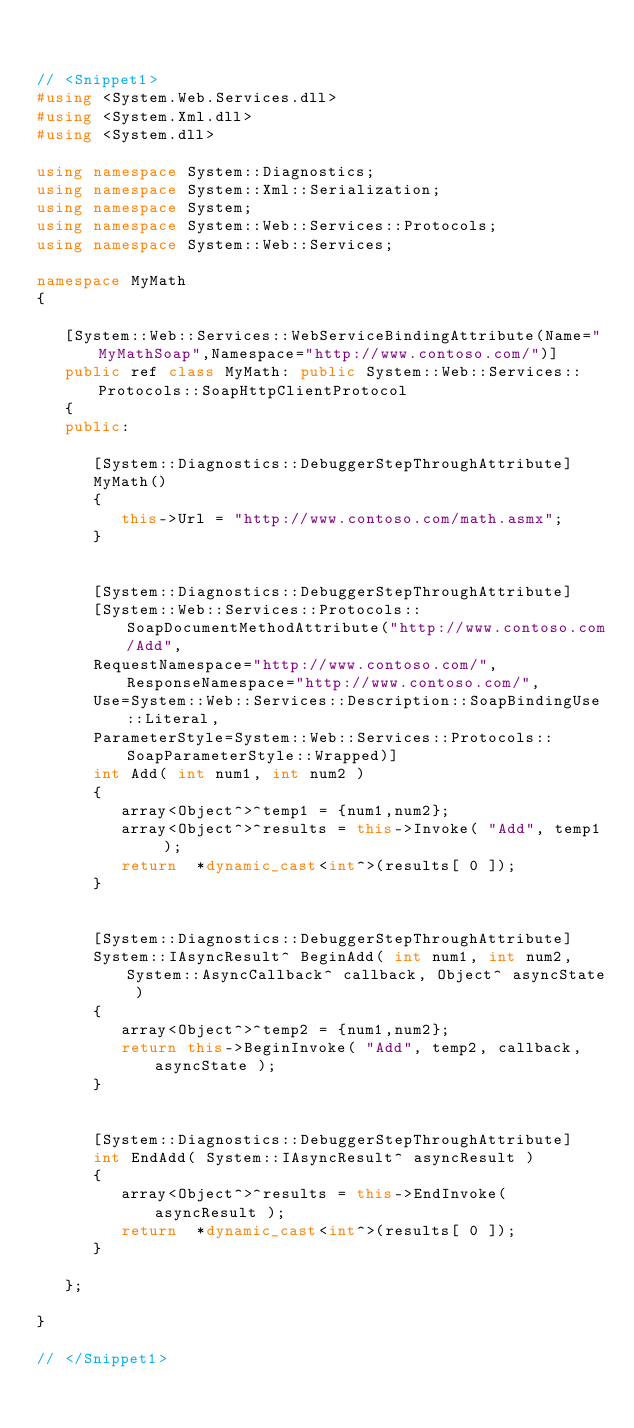Convert code to text. <code><loc_0><loc_0><loc_500><loc_500><_C++_>

// <Snippet1>
#using <System.Web.Services.dll>
#using <System.Xml.dll>
#using <System.dll>

using namespace System::Diagnostics;
using namespace System::Xml::Serialization;
using namespace System;
using namespace System::Web::Services::Protocols;
using namespace System::Web::Services;

namespace MyMath
{

   [System::Web::Services::WebServiceBindingAttribute(Name="MyMathSoap",Namespace="http://www.contoso.com/")]
   public ref class MyMath: public System::Web::Services::Protocols::SoapHttpClientProtocol
   {
   public:

      [System::Diagnostics::DebuggerStepThroughAttribute]
      MyMath()
      {
         this->Url = "http://www.contoso.com/math.asmx";
      }


      [System::Diagnostics::DebuggerStepThroughAttribute]
      [System::Web::Services::Protocols::SoapDocumentMethodAttribute("http://www.contoso.com/Add",
      RequestNamespace="http://www.contoso.com/",ResponseNamespace="http://www.contoso.com/",
      Use=System::Web::Services::Description::SoapBindingUse::Literal,
      ParameterStyle=System::Web::Services::Protocols::SoapParameterStyle::Wrapped)]
      int Add( int num1, int num2 )
      {
         array<Object^>^temp1 = {num1,num2};
         array<Object^>^results = this->Invoke( "Add", temp1 );
         return  *dynamic_cast<int^>(results[ 0 ]);
      }


      [System::Diagnostics::DebuggerStepThroughAttribute]
      System::IAsyncResult^ BeginAdd( int num1, int num2, System::AsyncCallback^ callback, Object^ asyncState )
      {
         array<Object^>^temp2 = {num1,num2};
         return this->BeginInvoke( "Add", temp2, callback, asyncState );
      }


      [System::Diagnostics::DebuggerStepThroughAttribute]
      int EndAdd( System::IAsyncResult^ asyncResult )
      {
         array<Object^>^results = this->EndInvoke( asyncResult );
         return  *dynamic_cast<int^>(results[ 0 ]);
      }

   };

}

// </Snippet1>
</code> 